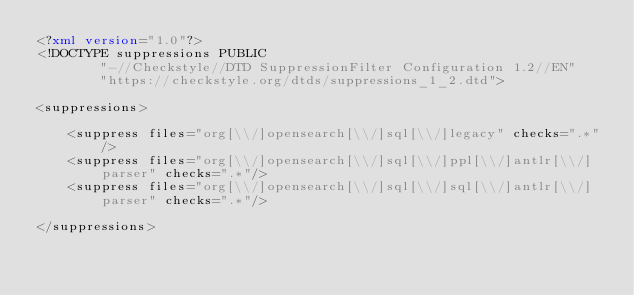<code> <loc_0><loc_0><loc_500><loc_500><_XML_><?xml version="1.0"?>
<!DOCTYPE suppressions PUBLIC
        "-//Checkstyle//DTD SuppressionFilter Configuration 1.2//EN"
        "https://checkstyle.org/dtds/suppressions_1_2.dtd">

<suppressions>

    <suppress files="org[\\/]opensearch[\\/]sql[\\/]legacy" checks=".*"/>
    <suppress files="org[\\/]opensearch[\\/]sql[\\/]ppl[\\/]antlr[\\/]parser" checks=".*"/>
    <suppress files="org[\\/]opensearch[\\/]sql[\\/]sql[\\/]antlr[\\/]parser" checks=".*"/>

</suppressions></code> 